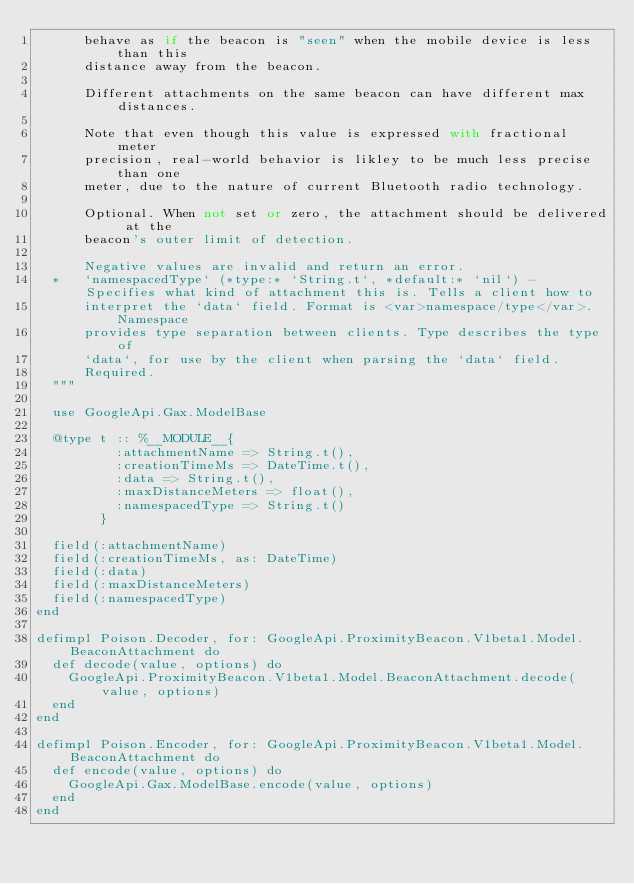Convert code to text. <code><loc_0><loc_0><loc_500><loc_500><_Elixir_>      behave as if the beacon is "seen" when the mobile device is less than this
      distance away from the beacon.

      Different attachments on the same beacon can have different max distances.

      Note that even though this value is expressed with fractional meter
      precision, real-world behavior is likley to be much less precise than one
      meter, due to the nature of current Bluetooth radio technology.

      Optional. When not set or zero, the attachment should be delivered at the
      beacon's outer limit of detection.

      Negative values are invalid and return an error.
  *   `namespacedType` (*type:* `String.t`, *default:* `nil`) - Specifies what kind of attachment this is. Tells a client how to
      interpret the `data` field. Format is <var>namespace/type</var>. Namespace
      provides type separation between clients. Type describes the type of
      `data`, for use by the client when parsing the `data` field.
      Required.
  """

  use GoogleApi.Gax.ModelBase

  @type t :: %__MODULE__{
          :attachmentName => String.t(),
          :creationTimeMs => DateTime.t(),
          :data => String.t(),
          :maxDistanceMeters => float(),
          :namespacedType => String.t()
        }

  field(:attachmentName)
  field(:creationTimeMs, as: DateTime)
  field(:data)
  field(:maxDistanceMeters)
  field(:namespacedType)
end

defimpl Poison.Decoder, for: GoogleApi.ProximityBeacon.V1beta1.Model.BeaconAttachment do
  def decode(value, options) do
    GoogleApi.ProximityBeacon.V1beta1.Model.BeaconAttachment.decode(value, options)
  end
end

defimpl Poison.Encoder, for: GoogleApi.ProximityBeacon.V1beta1.Model.BeaconAttachment do
  def encode(value, options) do
    GoogleApi.Gax.ModelBase.encode(value, options)
  end
end
</code> 